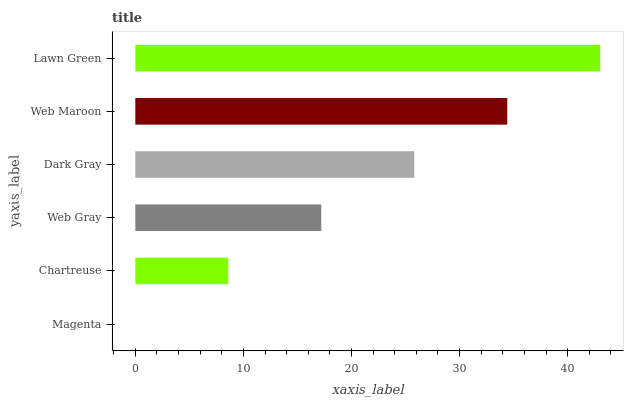Is Magenta the minimum?
Answer yes or no. Yes. Is Lawn Green the maximum?
Answer yes or no. Yes. Is Chartreuse the minimum?
Answer yes or no. No. Is Chartreuse the maximum?
Answer yes or no. No. Is Chartreuse greater than Magenta?
Answer yes or no. Yes. Is Magenta less than Chartreuse?
Answer yes or no. Yes. Is Magenta greater than Chartreuse?
Answer yes or no. No. Is Chartreuse less than Magenta?
Answer yes or no. No. Is Dark Gray the high median?
Answer yes or no. Yes. Is Web Gray the low median?
Answer yes or no. Yes. Is Lawn Green the high median?
Answer yes or no. No. Is Chartreuse the low median?
Answer yes or no. No. 